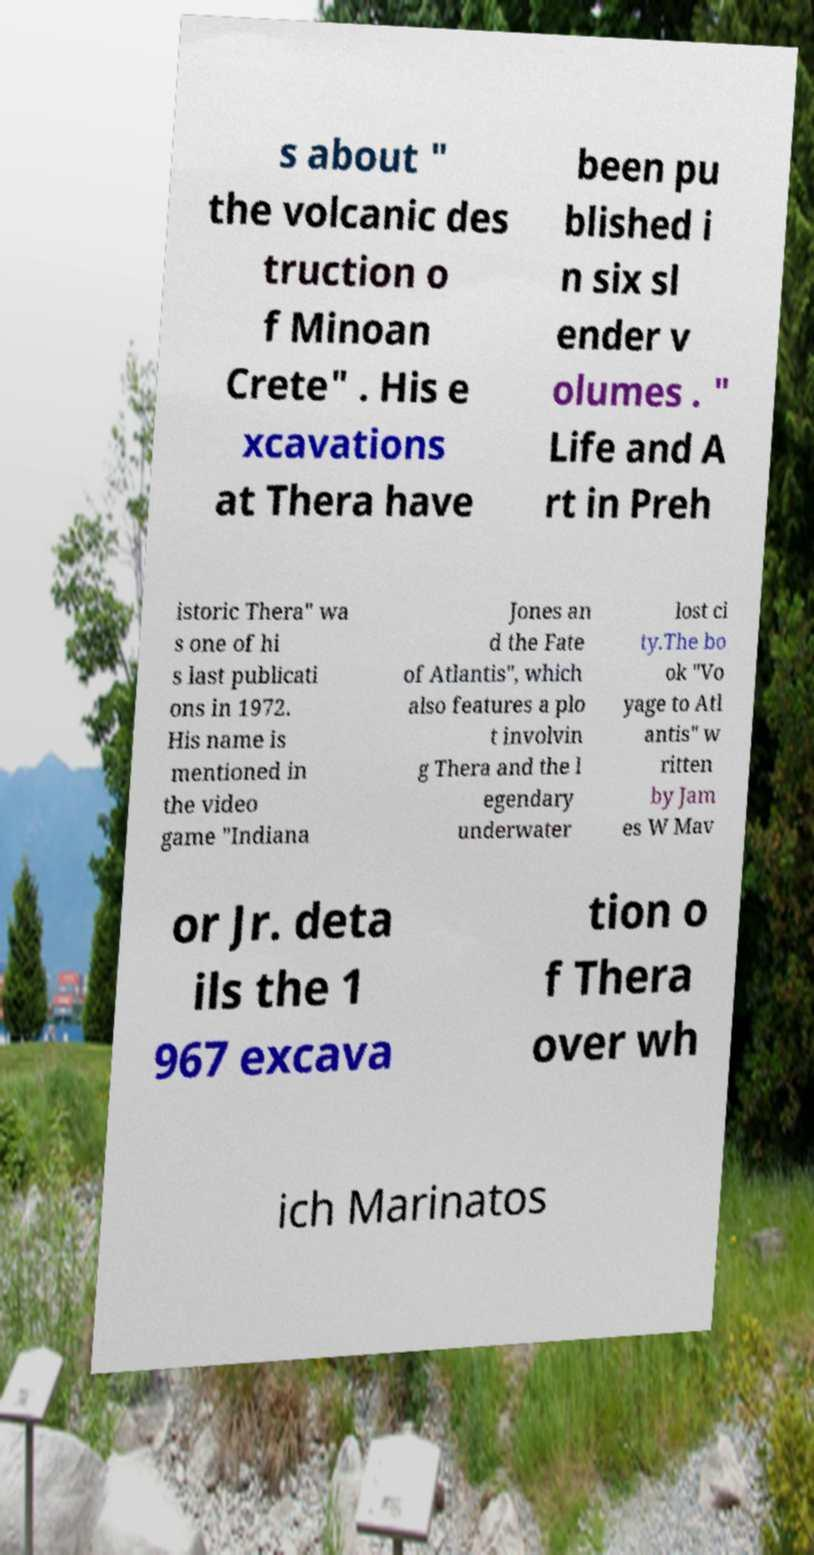For documentation purposes, I need the text within this image transcribed. Could you provide that? s about " the volcanic des truction o f Minoan Crete" . His e xcavations at Thera have been pu blished i n six sl ender v olumes . " Life and A rt in Preh istoric Thera" wa s one of hi s last publicati ons in 1972. His name is mentioned in the video game "Indiana Jones an d the Fate of Atlantis", which also features a plo t involvin g Thera and the l egendary underwater lost ci ty.The bo ok "Vo yage to Atl antis" w ritten by Jam es W Mav or Jr. deta ils the 1 967 excava tion o f Thera over wh ich Marinatos 